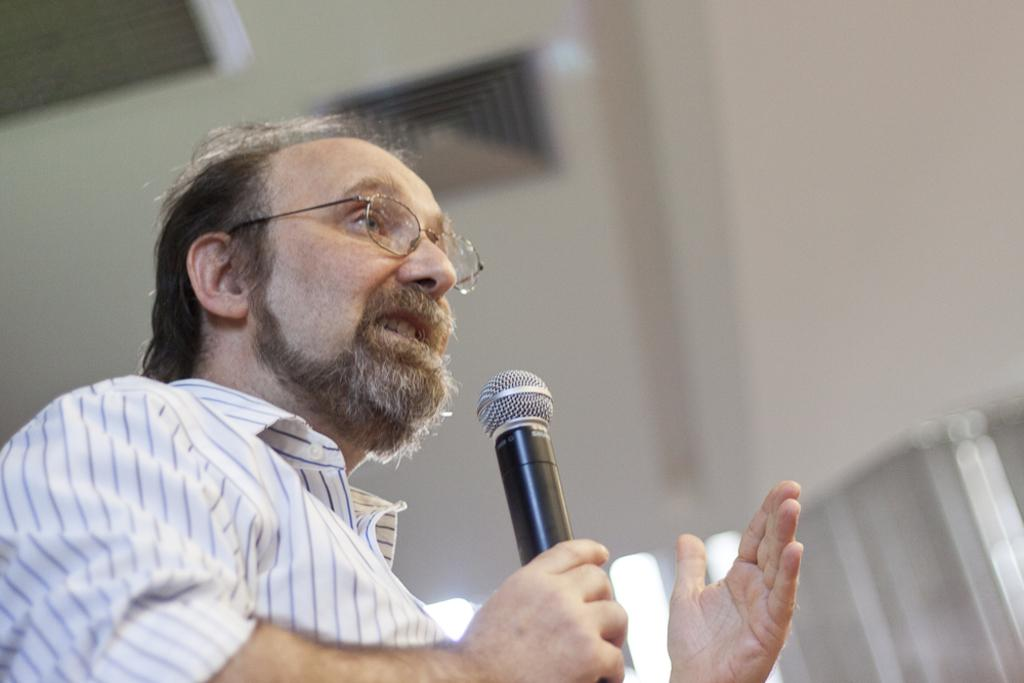What is the main subject of the image? There is a person in the image. What is the person holding in the image? The person is holding a microphone. What can be seen above the person in the image? There is a ceiling visible in the image. What type of show is the kitty performing in the image? There is no kitty present in the image, and therefore no show is being performed. 